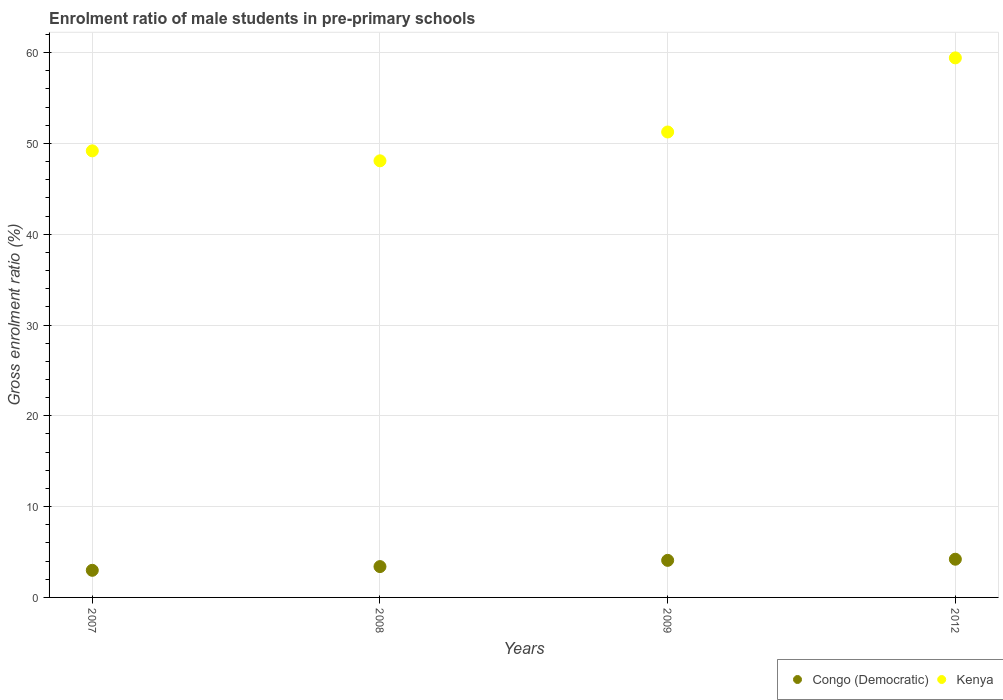What is the enrolment ratio of male students in pre-primary schools in Kenya in 2008?
Provide a succinct answer. 48.09. Across all years, what is the maximum enrolment ratio of male students in pre-primary schools in Congo (Democratic)?
Provide a short and direct response. 4.21. Across all years, what is the minimum enrolment ratio of male students in pre-primary schools in Kenya?
Your answer should be very brief. 48.09. In which year was the enrolment ratio of male students in pre-primary schools in Kenya maximum?
Give a very brief answer. 2012. In which year was the enrolment ratio of male students in pre-primary schools in Congo (Democratic) minimum?
Provide a short and direct response. 2007. What is the total enrolment ratio of male students in pre-primary schools in Congo (Democratic) in the graph?
Your answer should be compact. 14.67. What is the difference between the enrolment ratio of male students in pre-primary schools in Kenya in 2007 and that in 2012?
Offer a very short reply. -10.24. What is the difference between the enrolment ratio of male students in pre-primary schools in Kenya in 2008 and the enrolment ratio of male students in pre-primary schools in Congo (Democratic) in 2009?
Your answer should be compact. 44. What is the average enrolment ratio of male students in pre-primary schools in Congo (Democratic) per year?
Offer a very short reply. 3.67. In the year 2008, what is the difference between the enrolment ratio of male students in pre-primary schools in Congo (Democratic) and enrolment ratio of male students in pre-primary schools in Kenya?
Your response must be concise. -44.69. In how many years, is the enrolment ratio of male students in pre-primary schools in Kenya greater than 38 %?
Give a very brief answer. 4. What is the ratio of the enrolment ratio of male students in pre-primary schools in Kenya in 2008 to that in 2012?
Provide a short and direct response. 0.81. Is the difference between the enrolment ratio of male students in pre-primary schools in Congo (Democratic) in 2007 and 2009 greater than the difference between the enrolment ratio of male students in pre-primary schools in Kenya in 2007 and 2009?
Give a very brief answer. Yes. What is the difference between the highest and the second highest enrolment ratio of male students in pre-primary schools in Congo (Democratic)?
Offer a terse response. 0.13. What is the difference between the highest and the lowest enrolment ratio of male students in pre-primary schools in Congo (Democratic)?
Your response must be concise. 1.22. In how many years, is the enrolment ratio of male students in pre-primary schools in Kenya greater than the average enrolment ratio of male students in pre-primary schools in Kenya taken over all years?
Keep it short and to the point. 1. Is the sum of the enrolment ratio of male students in pre-primary schools in Kenya in 2008 and 2012 greater than the maximum enrolment ratio of male students in pre-primary schools in Congo (Democratic) across all years?
Provide a short and direct response. Yes. Does the enrolment ratio of male students in pre-primary schools in Kenya monotonically increase over the years?
Provide a short and direct response. No. Is the enrolment ratio of male students in pre-primary schools in Congo (Democratic) strictly greater than the enrolment ratio of male students in pre-primary schools in Kenya over the years?
Offer a terse response. No. How many dotlines are there?
Make the answer very short. 2. How many years are there in the graph?
Your response must be concise. 4. What is the difference between two consecutive major ticks on the Y-axis?
Your response must be concise. 10. Does the graph contain grids?
Ensure brevity in your answer.  Yes. Where does the legend appear in the graph?
Give a very brief answer. Bottom right. How many legend labels are there?
Provide a succinct answer. 2. How are the legend labels stacked?
Provide a succinct answer. Horizontal. What is the title of the graph?
Provide a succinct answer. Enrolment ratio of male students in pre-primary schools. Does "French Polynesia" appear as one of the legend labels in the graph?
Provide a short and direct response. No. What is the label or title of the X-axis?
Ensure brevity in your answer.  Years. What is the Gross enrolment ratio (%) of Congo (Democratic) in 2007?
Offer a very short reply. 2.99. What is the Gross enrolment ratio (%) of Kenya in 2007?
Offer a terse response. 49.19. What is the Gross enrolment ratio (%) in Congo (Democratic) in 2008?
Offer a terse response. 3.4. What is the Gross enrolment ratio (%) of Kenya in 2008?
Make the answer very short. 48.09. What is the Gross enrolment ratio (%) in Congo (Democratic) in 2009?
Provide a succinct answer. 4.08. What is the Gross enrolment ratio (%) in Kenya in 2009?
Your response must be concise. 51.26. What is the Gross enrolment ratio (%) in Congo (Democratic) in 2012?
Offer a terse response. 4.21. What is the Gross enrolment ratio (%) in Kenya in 2012?
Offer a very short reply. 59.43. Across all years, what is the maximum Gross enrolment ratio (%) of Congo (Democratic)?
Offer a terse response. 4.21. Across all years, what is the maximum Gross enrolment ratio (%) of Kenya?
Your answer should be compact. 59.43. Across all years, what is the minimum Gross enrolment ratio (%) of Congo (Democratic)?
Provide a succinct answer. 2.99. Across all years, what is the minimum Gross enrolment ratio (%) in Kenya?
Your answer should be compact. 48.09. What is the total Gross enrolment ratio (%) in Congo (Democratic) in the graph?
Make the answer very short. 14.67. What is the total Gross enrolment ratio (%) of Kenya in the graph?
Keep it short and to the point. 207.96. What is the difference between the Gross enrolment ratio (%) of Congo (Democratic) in 2007 and that in 2008?
Give a very brief answer. -0.41. What is the difference between the Gross enrolment ratio (%) of Kenya in 2007 and that in 2008?
Your response must be concise. 1.1. What is the difference between the Gross enrolment ratio (%) in Congo (Democratic) in 2007 and that in 2009?
Give a very brief answer. -1.1. What is the difference between the Gross enrolment ratio (%) in Kenya in 2007 and that in 2009?
Make the answer very short. -2.08. What is the difference between the Gross enrolment ratio (%) in Congo (Democratic) in 2007 and that in 2012?
Make the answer very short. -1.22. What is the difference between the Gross enrolment ratio (%) of Kenya in 2007 and that in 2012?
Your answer should be very brief. -10.24. What is the difference between the Gross enrolment ratio (%) of Congo (Democratic) in 2008 and that in 2009?
Give a very brief answer. -0.69. What is the difference between the Gross enrolment ratio (%) in Kenya in 2008 and that in 2009?
Your answer should be compact. -3.18. What is the difference between the Gross enrolment ratio (%) of Congo (Democratic) in 2008 and that in 2012?
Offer a terse response. -0.81. What is the difference between the Gross enrolment ratio (%) in Kenya in 2008 and that in 2012?
Offer a terse response. -11.34. What is the difference between the Gross enrolment ratio (%) in Congo (Democratic) in 2009 and that in 2012?
Keep it short and to the point. -0.13. What is the difference between the Gross enrolment ratio (%) in Kenya in 2009 and that in 2012?
Keep it short and to the point. -8.16. What is the difference between the Gross enrolment ratio (%) in Congo (Democratic) in 2007 and the Gross enrolment ratio (%) in Kenya in 2008?
Give a very brief answer. -45.1. What is the difference between the Gross enrolment ratio (%) of Congo (Democratic) in 2007 and the Gross enrolment ratio (%) of Kenya in 2009?
Provide a succinct answer. -48.28. What is the difference between the Gross enrolment ratio (%) of Congo (Democratic) in 2007 and the Gross enrolment ratio (%) of Kenya in 2012?
Make the answer very short. -56.44. What is the difference between the Gross enrolment ratio (%) in Congo (Democratic) in 2008 and the Gross enrolment ratio (%) in Kenya in 2009?
Provide a short and direct response. -47.87. What is the difference between the Gross enrolment ratio (%) of Congo (Democratic) in 2008 and the Gross enrolment ratio (%) of Kenya in 2012?
Give a very brief answer. -56.03. What is the difference between the Gross enrolment ratio (%) in Congo (Democratic) in 2009 and the Gross enrolment ratio (%) in Kenya in 2012?
Ensure brevity in your answer.  -55.34. What is the average Gross enrolment ratio (%) in Congo (Democratic) per year?
Ensure brevity in your answer.  3.67. What is the average Gross enrolment ratio (%) in Kenya per year?
Give a very brief answer. 51.99. In the year 2007, what is the difference between the Gross enrolment ratio (%) in Congo (Democratic) and Gross enrolment ratio (%) in Kenya?
Make the answer very short. -46.2. In the year 2008, what is the difference between the Gross enrolment ratio (%) of Congo (Democratic) and Gross enrolment ratio (%) of Kenya?
Make the answer very short. -44.69. In the year 2009, what is the difference between the Gross enrolment ratio (%) of Congo (Democratic) and Gross enrolment ratio (%) of Kenya?
Give a very brief answer. -47.18. In the year 2012, what is the difference between the Gross enrolment ratio (%) of Congo (Democratic) and Gross enrolment ratio (%) of Kenya?
Make the answer very short. -55.22. What is the ratio of the Gross enrolment ratio (%) of Congo (Democratic) in 2007 to that in 2008?
Keep it short and to the point. 0.88. What is the ratio of the Gross enrolment ratio (%) of Kenya in 2007 to that in 2008?
Offer a terse response. 1.02. What is the ratio of the Gross enrolment ratio (%) in Congo (Democratic) in 2007 to that in 2009?
Provide a succinct answer. 0.73. What is the ratio of the Gross enrolment ratio (%) of Kenya in 2007 to that in 2009?
Ensure brevity in your answer.  0.96. What is the ratio of the Gross enrolment ratio (%) of Congo (Democratic) in 2007 to that in 2012?
Offer a very short reply. 0.71. What is the ratio of the Gross enrolment ratio (%) of Kenya in 2007 to that in 2012?
Your response must be concise. 0.83. What is the ratio of the Gross enrolment ratio (%) of Congo (Democratic) in 2008 to that in 2009?
Provide a short and direct response. 0.83. What is the ratio of the Gross enrolment ratio (%) in Kenya in 2008 to that in 2009?
Your answer should be very brief. 0.94. What is the ratio of the Gross enrolment ratio (%) of Congo (Democratic) in 2008 to that in 2012?
Give a very brief answer. 0.81. What is the ratio of the Gross enrolment ratio (%) in Kenya in 2008 to that in 2012?
Offer a very short reply. 0.81. What is the ratio of the Gross enrolment ratio (%) of Congo (Democratic) in 2009 to that in 2012?
Your answer should be very brief. 0.97. What is the ratio of the Gross enrolment ratio (%) in Kenya in 2009 to that in 2012?
Your answer should be very brief. 0.86. What is the difference between the highest and the second highest Gross enrolment ratio (%) of Congo (Democratic)?
Ensure brevity in your answer.  0.13. What is the difference between the highest and the second highest Gross enrolment ratio (%) in Kenya?
Give a very brief answer. 8.16. What is the difference between the highest and the lowest Gross enrolment ratio (%) in Congo (Democratic)?
Ensure brevity in your answer.  1.22. What is the difference between the highest and the lowest Gross enrolment ratio (%) of Kenya?
Your response must be concise. 11.34. 